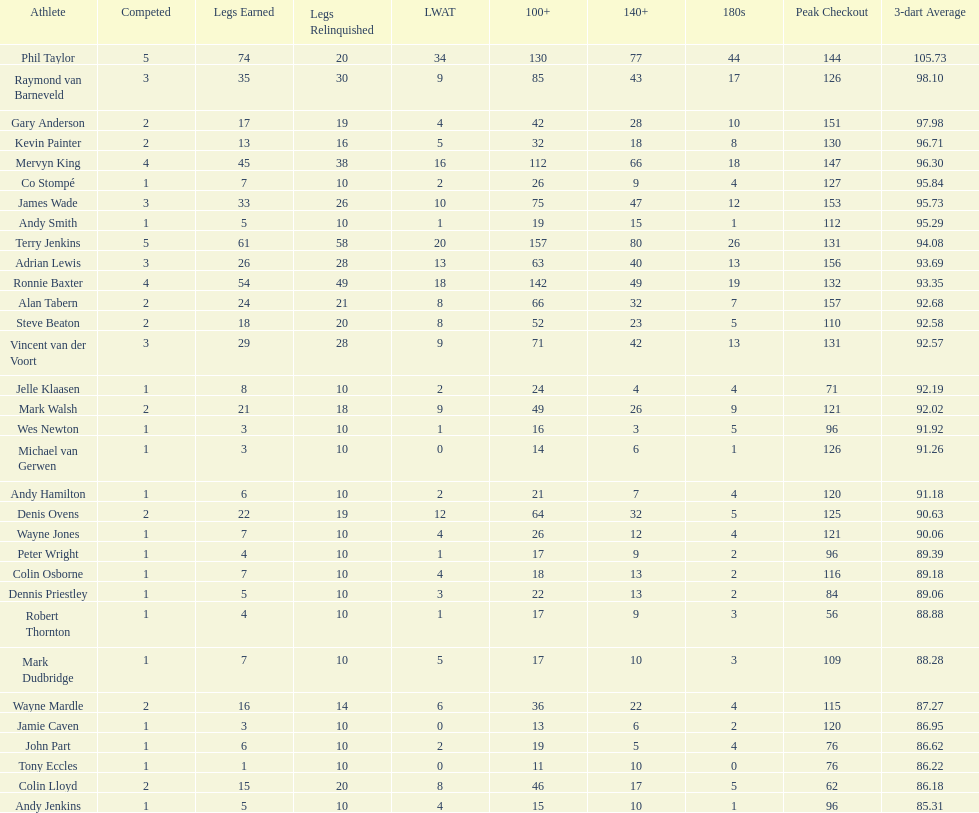What were the total number of legs won by ronnie baxter? 54. 